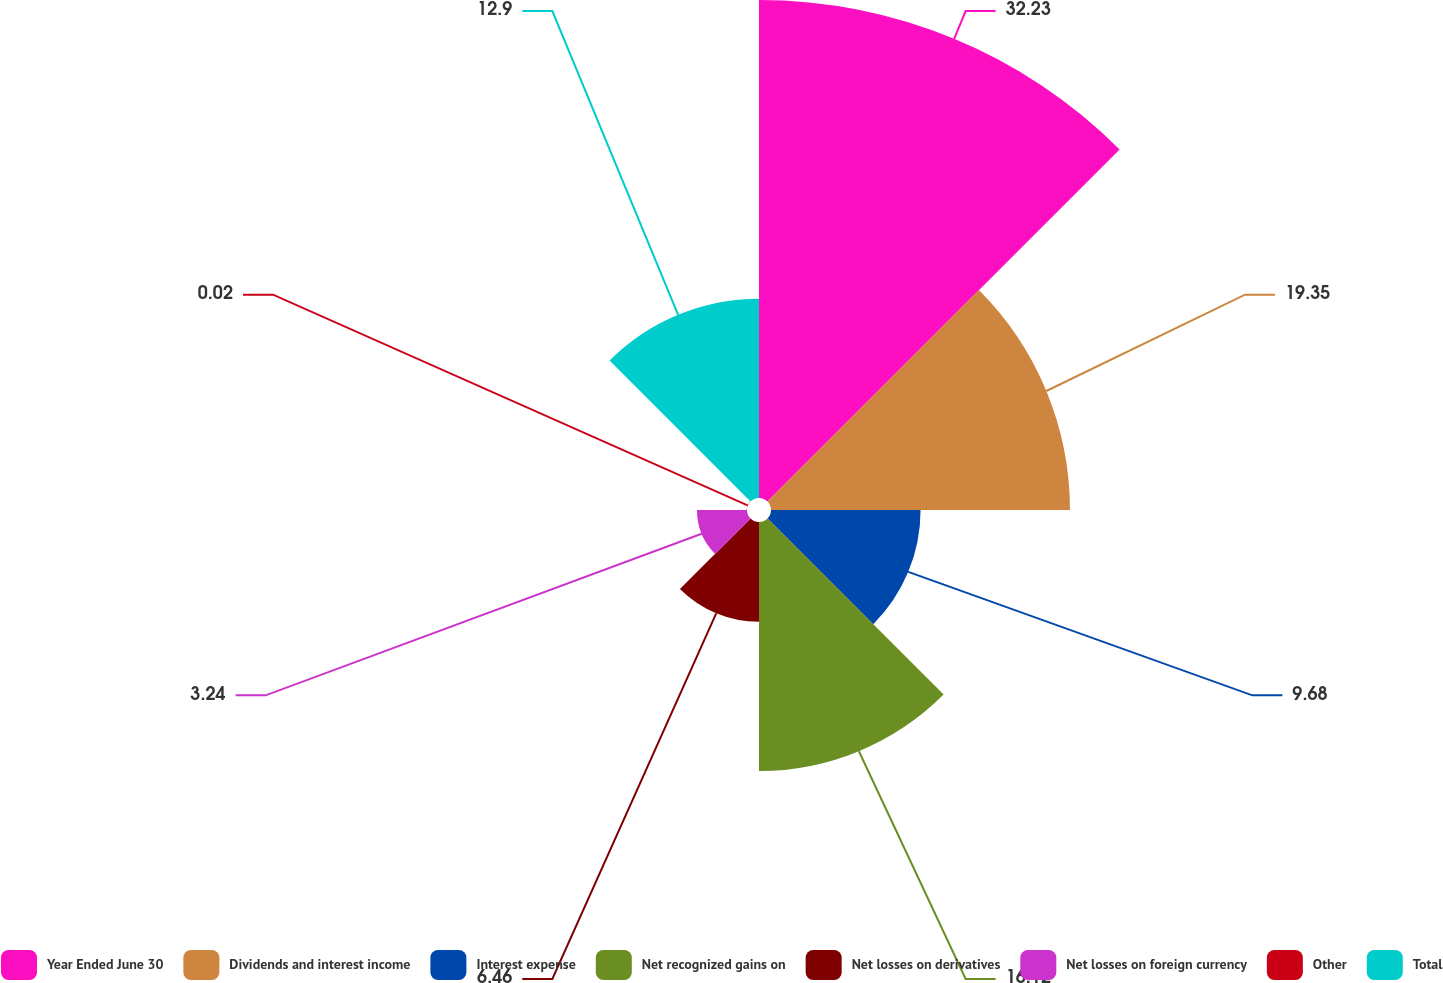<chart> <loc_0><loc_0><loc_500><loc_500><pie_chart><fcel>Year Ended June 30<fcel>Dividends and interest income<fcel>Interest expense<fcel>Net recognized gains on<fcel>Net losses on derivatives<fcel>Net losses on foreign currency<fcel>Other<fcel>Total<nl><fcel>32.23%<fcel>19.35%<fcel>9.68%<fcel>16.12%<fcel>6.46%<fcel>3.24%<fcel>0.02%<fcel>12.9%<nl></chart> 